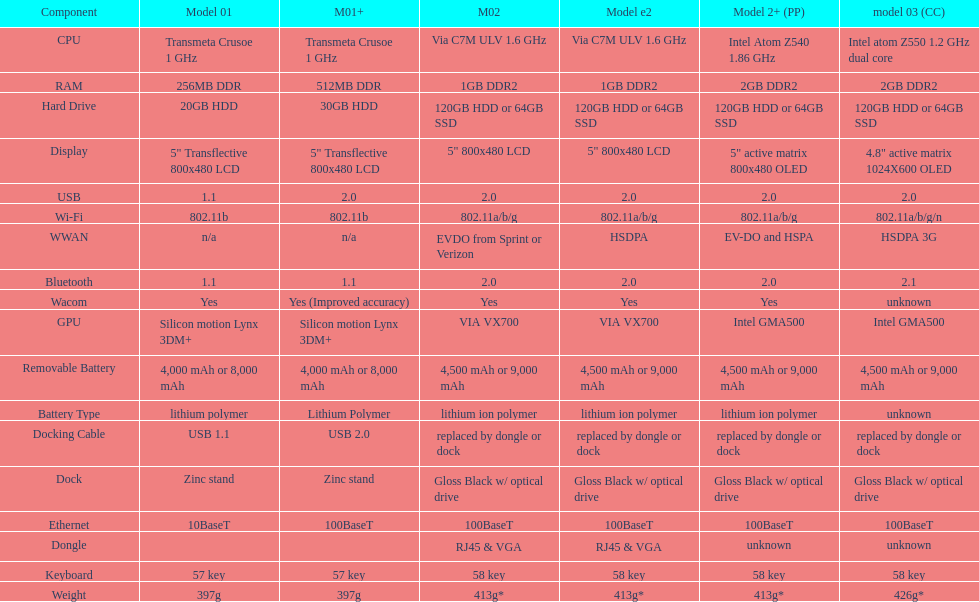Which model weighs the most, according to the table? Model 03 (china copy). 